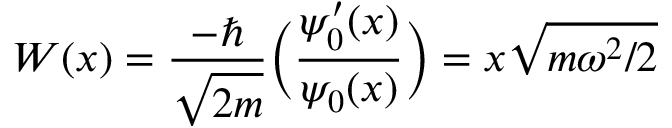<formula> <loc_0><loc_0><loc_500><loc_500>W ( x ) = { \frac { - } { \sqrt { 2 m } } } { \left ( } { \frac { \psi _ { 0 } ^ { \prime } ( x ) } { \psi _ { 0 } ( x ) } } { \right ) } = x { \sqrt { m \omega ^ { 2 } / 2 } }</formula> 